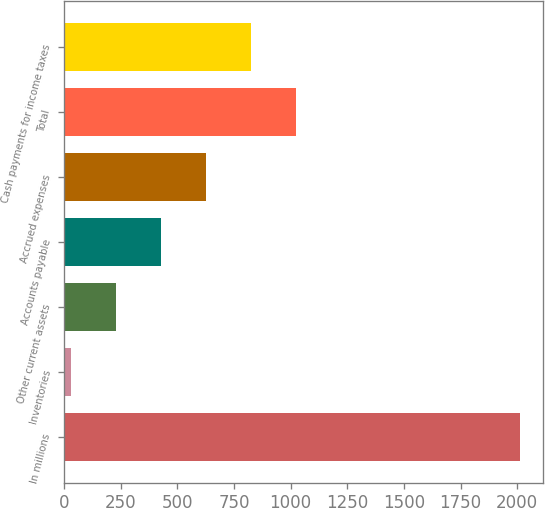Convert chart. <chart><loc_0><loc_0><loc_500><loc_500><bar_chart><fcel>In millions<fcel>Inventories<fcel>Other current assets<fcel>Accounts payable<fcel>Accrued expenses<fcel>Total<fcel>Cash payments for income taxes<nl><fcel>2012<fcel>32<fcel>230<fcel>428<fcel>626<fcel>1022<fcel>824<nl></chart> 